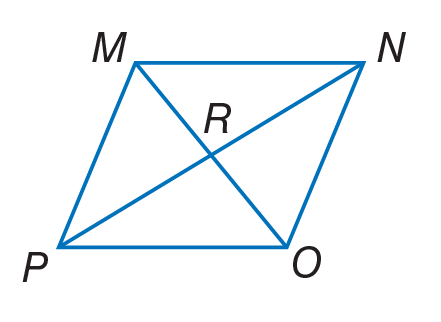Answer the mathemtical geometry problem and directly provide the correct option letter.
Question: Quadrilateral M N O P is a rhombus. Find m \angle M R N.
Choices: A: 56 B: 90 C: 124 D: 140 B 